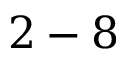Convert formula to latex. <formula><loc_0><loc_0><loc_500><loc_500>2 - 8</formula> 